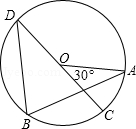First perform reasoning, then finally select the question from the choices in the following format: Answer: xxx.
Question: Consider the circle O, with A, B, C, D as the four vertices and CD as the diameter. If the degree of angle AOC is 'gamma', determine the degree of angle ABD denoted as 'delta', expressed in terms of 'gamma'.
Choices:
A: 55°
B: 65°
C: 75°
D: 85° After determining the measure of angle AOD as 180° minus angle AOC, resulting in 180° - gamma, we express the measure of angle ABD as half of angle AOD, denoted as delta = (1/2)*(180° - gamma). Therefore, the degree of angle ABD in terms of 'gamma' is delta = (1/2)*(180° - gamma). Hence, when gamma = 30°, the measure of angle ABD becomes 75°. Therefore, the answer is option C.
Answer:C 